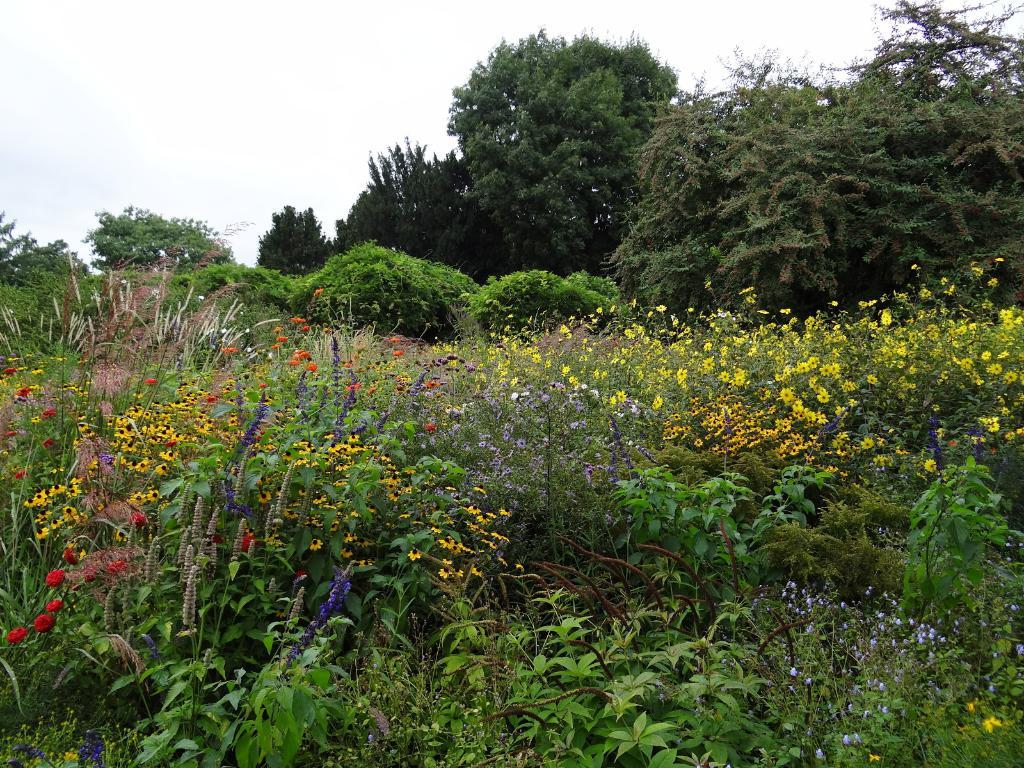What type of outdoor space is shown in the image? There is a beautiful garden in the image. What can be found within the garden? The garden contains flowers. What is visible in the background of the image? There are trees and a cloudy sky in the background of the image. What type of guitar can be seen hanging on the tree in the image? There is no guitar present in the image; it features a beautiful garden with flowers and trees. What activity is taking place in the garden in the image? The image does not depict any specific activity; it simply shows the garden with flowers and trees. 